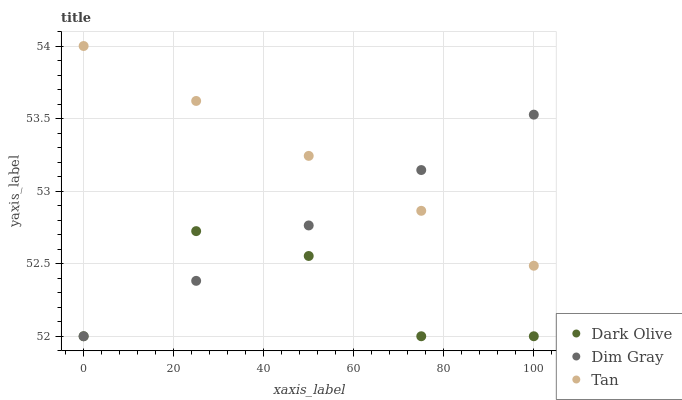Does Dark Olive have the minimum area under the curve?
Answer yes or no. Yes. Does Tan have the maximum area under the curve?
Answer yes or no. Yes. Does Tan have the minimum area under the curve?
Answer yes or no. No. Does Dark Olive have the maximum area under the curve?
Answer yes or no. No. Is Tan the smoothest?
Answer yes or no. Yes. Is Dark Olive the roughest?
Answer yes or no. Yes. Is Dark Olive the smoothest?
Answer yes or no. No. Is Tan the roughest?
Answer yes or no. No. Does Dim Gray have the lowest value?
Answer yes or no. Yes. Does Tan have the lowest value?
Answer yes or no. No. Does Tan have the highest value?
Answer yes or no. Yes. Does Dark Olive have the highest value?
Answer yes or no. No. Is Dark Olive less than Tan?
Answer yes or no. Yes. Is Tan greater than Dark Olive?
Answer yes or no. Yes. Does Dark Olive intersect Dim Gray?
Answer yes or no. Yes. Is Dark Olive less than Dim Gray?
Answer yes or no. No. Is Dark Olive greater than Dim Gray?
Answer yes or no. No. Does Dark Olive intersect Tan?
Answer yes or no. No. 